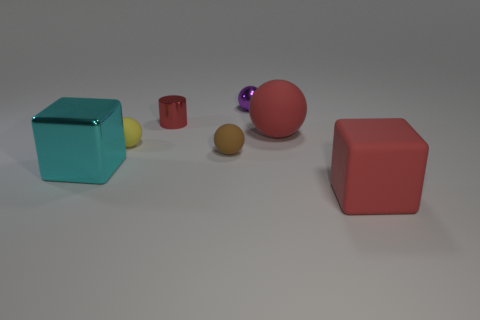Do the cyan block and the brown thing have the same size?
Provide a succinct answer. No. What is the size of the purple shiny ball?
Ensure brevity in your answer.  Small. What material is the purple thing that is the same shape as the brown thing?
Make the answer very short. Metal. What color is the matte block?
Your answer should be compact. Red. How many objects are either small purple shiny balls or tiny yellow spheres?
Provide a short and direct response. 2. There is a large red matte object behind the big red matte cube to the right of the brown matte object; what is its shape?
Your answer should be very brief. Sphere. How many other things are the same material as the small brown sphere?
Your answer should be very brief. 3. Is the brown thing made of the same material as the large block left of the purple object?
Provide a succinct answer. No. How many things are matte objects that are behind the yellow ball or red objects that are in front of the tiny yellow rubber object?
Provide a short and direct response. 2. How many other things are there of the same color as the rubber block?
Ensure brevity in your answer.  2. 